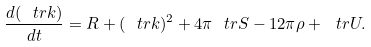<formula> <loc_0><loc_0><loc_500><loc_500>\frac { d ( \ t r k ) } { d t } = R + ( \ t r k ) ^ { 2 } + 4 \pi \ t r S - 1 2 \pi \rho + \ t r U .</formula> 